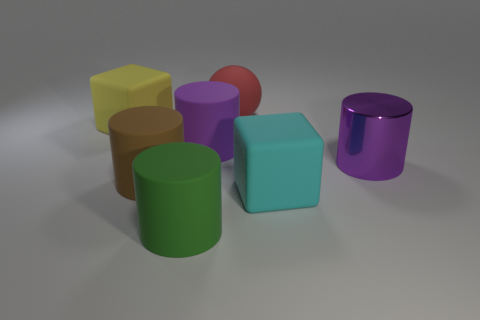What shape is the matte thing that is the same color as the metallic cylinder?
Offer a terse response. Cylinder. How many yellow matte spheres are the same size as the brown object?
Make the answer very short. 0. What number of rubber cubes are to the right of the purple matte thing?
Provide a short and direct response. 1. There is a cylinder right of the purple cylinder that is left of the large red sphere; what is its material?
Offer a very short reply. Metal. Are there any spheres that have the same color as the large shiny cylinder?
Your response must be concise. No. What is the size of the yellow cube that is made of the same material as the cyan cube?
Offer a terse response. Large. Is there anything else that is the same color as the large shiny thing?
Keep it short and to the point. Yes. What color is the big rubber cube that is right of the big matte ball?
Ensure brevity in your answer.  Cyan. There is a matte block in front of the block that is to the left of the large green thing; is there a big cyan thing that is behind it?
Offer a very short reply. No. Are there more cyan rubber things behind the big yellow cube than red matte objects?
Offer a terse response. No. 